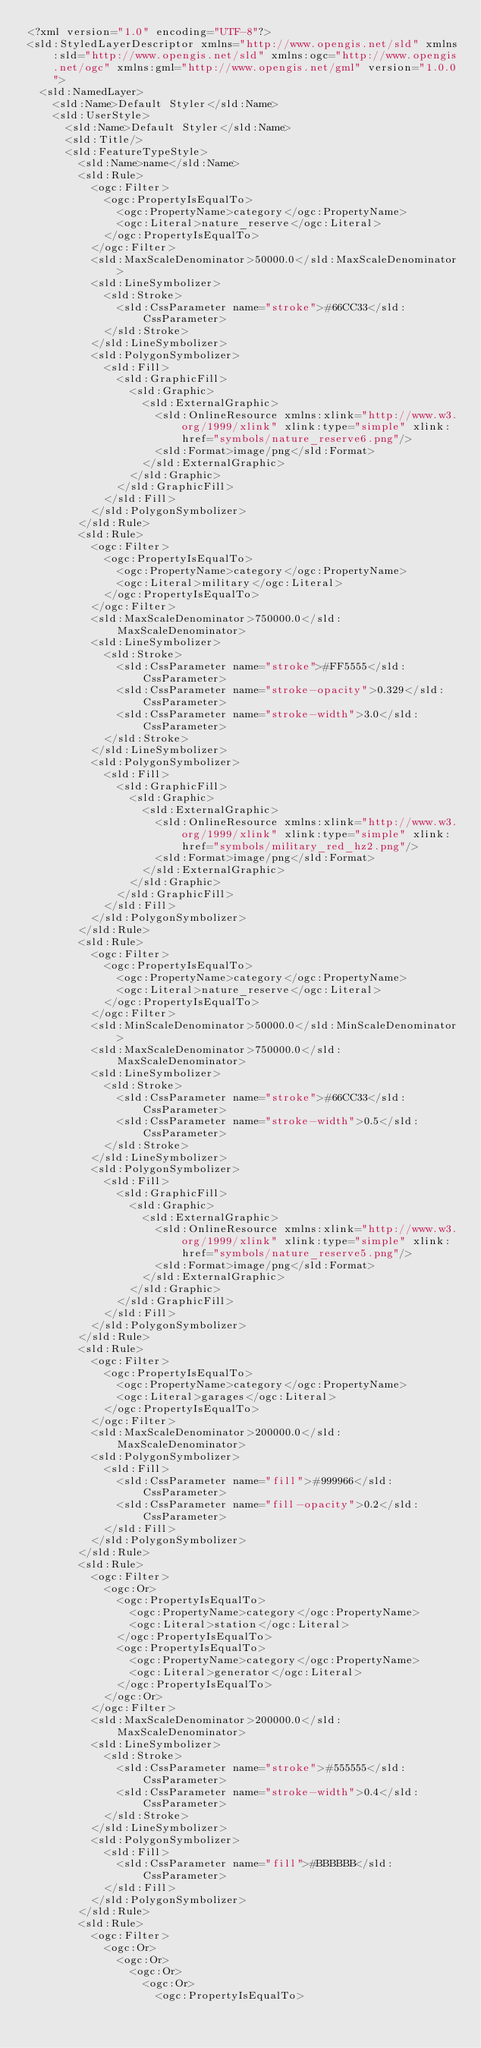Convert code to text. <code><loc_0><loc_0><loc_500><loc_500><_Scheme_><?xml version="1.0" encoding="UTF-8"?>
<sld:StyledLayerDescriptor xmlns="http://www.opengis.net/sld" xmlns:sld="http://www.opengis.net/sld" xmlns:ogc="http://www.opengis.net/ogc" xmlns:gml="http://www.opengis.net/gml" version="1.0.0">
  <sld:NamedLayer>
    <sld:Name>Default Styler</sld:Name>
    <sld:UserStyle>
      <sld:Name>Default Styler</sld:Name>
      <sld:Title/>
      <sld:FeatureTypeStyle>
        <sld:Name>name</sld:Name>
        <sld:Rule>
          <ogc:Filter>
            <ogc:PropertyIsEqualTo>
              <ogc:PropertyName>category</ogc:PropertyName>
              <ogc:Literal>nature_reserve</ogc:Literal>
            </ogc:PropertyIsEqualTo>
          </ogc:Filter>
          <sld:MaxScaleDenominator>50000.0</sld:MaxScaleDenominator>
          <sld:LineSymbolizer>
            <sld:Stroke>
              <sld:CssParameter name="stroke">#66CC33</sld:CssParameter>
            </sld:Stroke>
          </sld:LineSymbolizer>
          <sld:PolygonSymbolizer>
            <sld:Fill>
              <sld:GraphicFill>
                <sld:Graphic>
                  <sld:ExternalGraphic>
                    <sld:OnlineResource xmlns:xlink="http://www.w3.org/1999/xlink" xlink:type="simple" xlink:href="symbols/nature_reserve6.png"/>
                    <sld:Format>image/png</sld:Format>
                  </sld:ExternalGraphic>
                </sld:Graphic>
              </sld:GraphicFill>
            </sld:Fill>
          </sld:PolygonSymbolizer>
        </sld:Rule>
        <sld:Rule>
          <ogc:Filter>
            <ogc:PropertyIsEqualTo>
              <ogc:PropertyName>category</ogc:PropertyName>
              <ogc:Literal>military</ogc:Literal>
            </ogc:PropertyIsEqualTo>
          </ogc:Filter>
          <sld:MaxScaleDenominator>750000.0</sld:MaxScaleDenominator>
          <sld:LineSymbolizer>
            <sld:Stroke>
              <sld:CssParameter name="stroke">#FF5555</sld:CssParameter>
              <sld:CssParameter name="stroke-opacity">0.329</sld:CssParameter>
              <sld:CssParameter name="stroke-width">3.0</sld:CssParameter>
            </sld:Stroke>
          </sld:LineSymbolizer>
          <sld:PolygonSymbolizer>
            <sld:Fill>
              <sld:GraphicFill>
                <sld:Graphic>
                  <sld:ExternalGraphic>
                    <sld:OnlineResource xmlns:xlink="http://www.w3.org/1999/xlink" xlink:type="simple" xlink:href="symbols/military_red_hz2.png"/>
                    <sld:Format>image/png</sld:Format>
                  </sld:ExternalGraphic>
                </sld:Graphic>
              </sld:GraphicFill>
            </sld:Fill>
          </sld:PolygonSymbolizer>
        </sld:Rule>
        <sld:Rule>
          <ogc:Filter>
            <ogc:PropertyIsEqualTo>
              <ogc:PropertyName>category</ogc:PropertyName>
              <ogc:Literal>nature_reserve</ogc:Literal>
            </ogc:PropertyIsEqualTo>
          </ogc:Filter>
          <sld:MinScaleDenominator>50000.0</sld:MinScaleDenominator>
          <sld:MaxScaleDenominator>750000.0</sld:MaxScaleDenominator>
          <sld:LineSymbolizer>
            <sld:Stroke>
              <sld:CssParameter name="stroke">#66CC33</sld:CssParameter>
              <sld:CssParameter name="stroke-width">0.5</sld:CssParameter>
            </sld:Stroke>
          </sld:LineSymbolizer>
          <sld:PolygonSymbolizer>
            <sld:Fill>
              <sld:GraphicFill>
                <sld:Graphic>
                  <sld:ExternalGraphic>
                    <sld:OnlineResource xmlns:xlink="http://www.w3.org/1999/xlink" xlink:type="simple" xlink:href="symbols/nature_reserve5.png"/>
                    <sld:Format>image/png</sld:Format>
                  </sld:ExternalGraphic>
                </sld:Graphic>
              </sld:GraphicFill>
            </sld:Fill>
          </sld:PolygonSymbolizer>
        </sld:Rule>
        <sld:Rule>
          <ogc:Filter>
            <ogc:PropertyIsEqualTo>
              <ogc:PropertyName>category</ogc:PropertyName>
              <ogc:Literal>garages</ogc:Literal>
            </ogc:PropertyIsEqualTo>
          </ogc:Filter>
          <sld:MaxScaleDenominator>200000.0</sld:MaxScaleDenominator>
          <sld:PolygonSymbolizer>
            <sld:Fill>
              <sld:CssParameter name="fill">#999966</sld:CssParameter>
              <sld:CssParameter name="fill-opacity">0.2</sld:CssParameter>
            </sld:Fill>
          </sld:PolygonSymbolizer>
        </sld:Rule>
        <sld:Rule>
          <ogc:Filter>
            <ogc:Or>
              <ogc:PropertyIsEqualTo>
                <ogc:PropertyName>category</ogc:PropertyName>
                <ogc:Literal>station</ogc:Literal>
              </ogc:PropertyIsEqualTo>
              <ogc:PropertyIsEqualTo>
                <ogc:PropertyName>category</ogc:PropertyName>
                <ogc:Literal>generator</ogc:Literal>
              </ogc:PropertyIsEqualTo>
            </ogc:Or>
          </ogc:Filter>
          <sld:MaxScaleDenominator>200000.0</sld:MaxScaleDenominator>
          <sld:LineSymbolizer>
            <sld:Stroke>
              <sld:CssParameter name="stroke">#555555</sld:CssParameter>
              <sld:CssParameter name="stroke-width">0.4</sld:CssParameter>
            </sld:Stroke>
          </sld:LineSymbolizer>
          <sld:PolygonSymbolizer>
            <sld:Fill>
              <sld:CssParameter name="fill">#BBBBBB</sld:CssParameter>
            </sld:Fill>
          </sld:PolygonSymbolizer>
        </sld:Rule>
        <sld:Rule>
          <ogc:Filter>
            <ogc:Or>
              <ogc:Or>
                <ogc:Or>
                  <ogc:Or>
                    <ogc:PropertyIsEqualTo></code> 